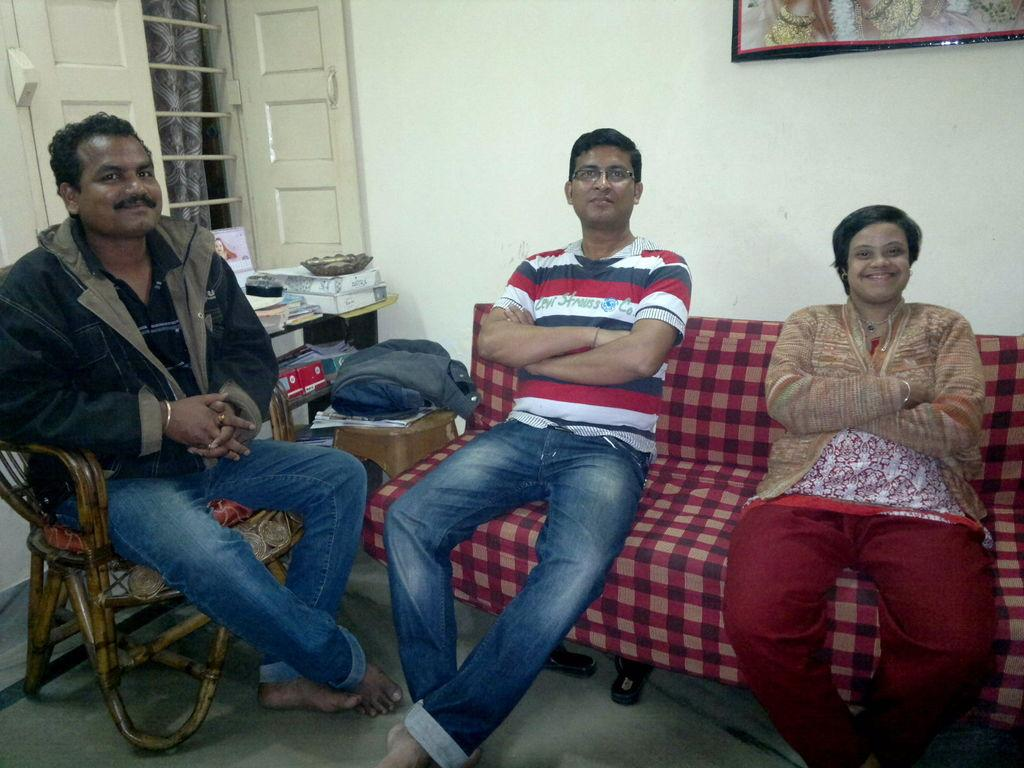How many people are sitting in the image? There are three people sitting in the image. What can be seen on the right side of the image? There are objects on a table to the right. Is there any source of natural light in the image? Yes, there is a window in the image. What is hanging on the wall in the image? There is a frame on the wall. What type of shoe is visible on the table in the image? There is no shoe present on the table in the image. 